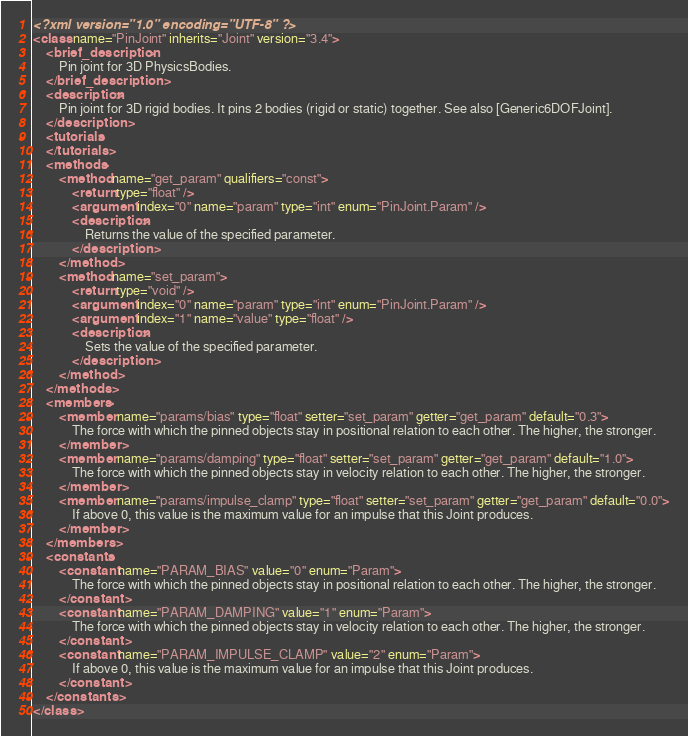<code> <loc_0><loc_0><loc_500><loc_500><_XML_><?xml version="1.0" encoding="UTF-8" ?>
<class name="PinJoint" inherits="Joint" version="3.4">
	<brief_description>
		Pin joint for 3D PhysicsBodies.
	</brief_description>
	<description>
		Pin joint for 3D rigid bodies. It pins 2 bodies (rigid or static) together. See also [Generic6DOFJoint].
	</description>
	<tutorials>
	</tutorials>
	<methods>
		<method name="get_param" qualifiers="const">
			<return type="float" />
			<argument index="0" name="param" type="int" enum="PinJoint.Param" />
			<description>
				Returns the value of the specified parameter.
			</description>
		</method>
		<method name="set_param">
			<return type="void" />
			<argument index="0" name="param" type="int" enum="PinJoint.Param" />
			<argument index="1" name="value" type="float" />
			<description>
				Sets the value of the specified parameter.
			</description>
		</method>
	</methods>
	<members>
		<member name="params/bias" type="float" setter="set_param" getter="get_param" default="0.3">
			The force with which the pinned objects stay in positional relation to each other. The higher, the stronger.
		</member>
		<member name="params/damping" type="float" setter="set_param" getter="get_param" default="1.0">
			The force with which the pinned objects stay in velocity relation to each other. The higher, the stronger.
		</member>
		<member name="params/impulse_clamp" type="float" setter="set_param" getter="get_param" default="0.0">
			If above 0, this value is the maximum value for an impulse that this Joint produces.
		</member>
	</members>
	<constants>
		<constant name="PARAM_BIAS" value="0" enum="Param">
			The force with which the pinned objects stay in positional relation to each other. The higher, the stronger.
		</constant>
		<constant name="PARAM_DAMPING" value="1" enum="Param">
			The force with which the pinned objects stay in velocity relation to each other. The higher, the stronger.
		</constant>
		<constant name="PARAM_IMPULSE_CLAMP" value="2" enum="Param">
			If above 0, this value is the maximum value for an impulse that this Joint produces.
		</constant>
	</constants>
</class>
</code> 